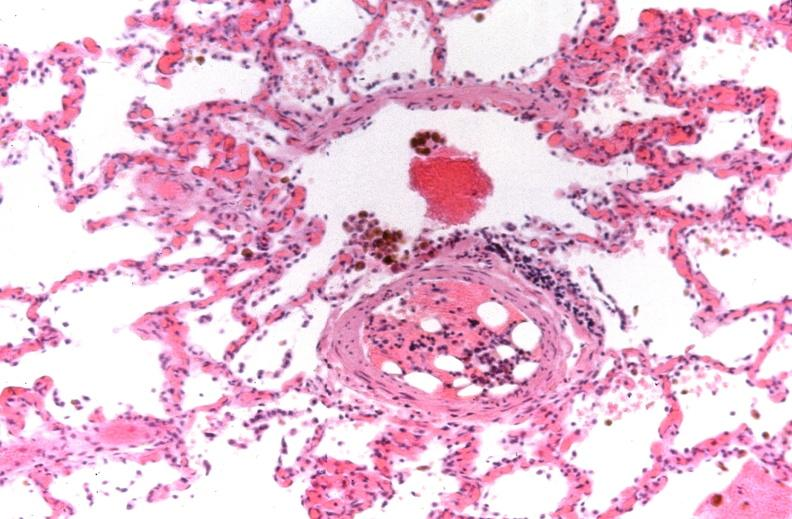s papillary intraductal adenocarcinoma present?
Answer the question using a single word or phrase. No 